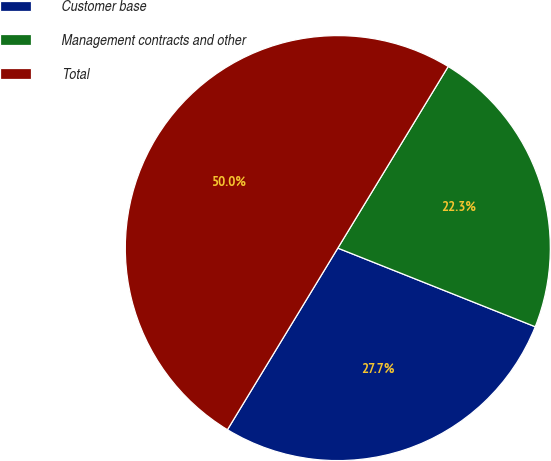<chart> <loc_0><loc_0><loc_500><loc_500><pie_chart><fcel>Customer base<fcel>Management contracts and other<fcel>Total<nl><fcel>27.66%<fcel>22.34%<fcel>50.0%<nl></chart> 